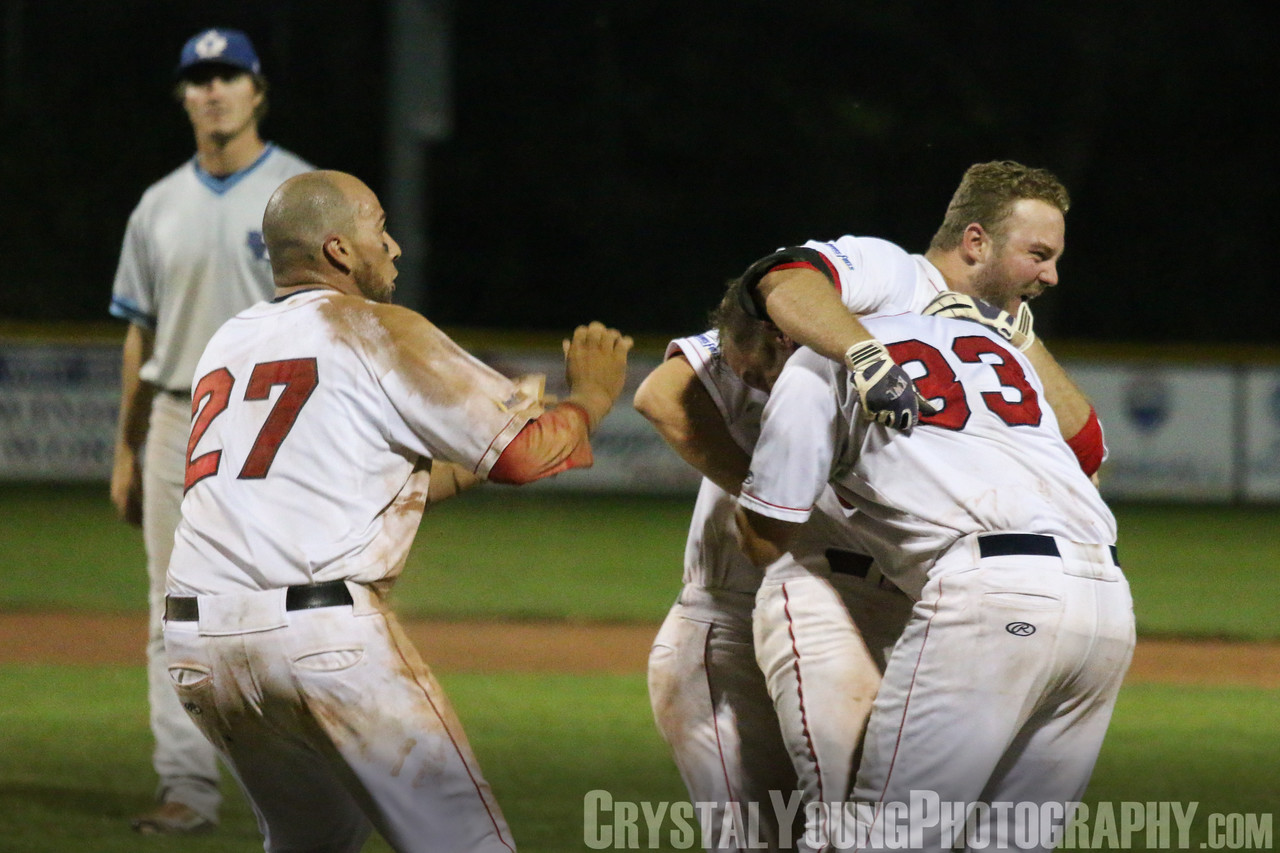What was the critical moment that led to the players celebrating in such a way? The critical moment that led to such jubilant celebration was likely a game-winning play, perhaps a walk-off hit or a crucial out that secured their victory. The intensity of the players' embrace, the visible expressions of elation, and the very enthusiastic manner in which they are celebrating all point towards a moment of high importance that dramatically turned the tide of the game in their favor. 